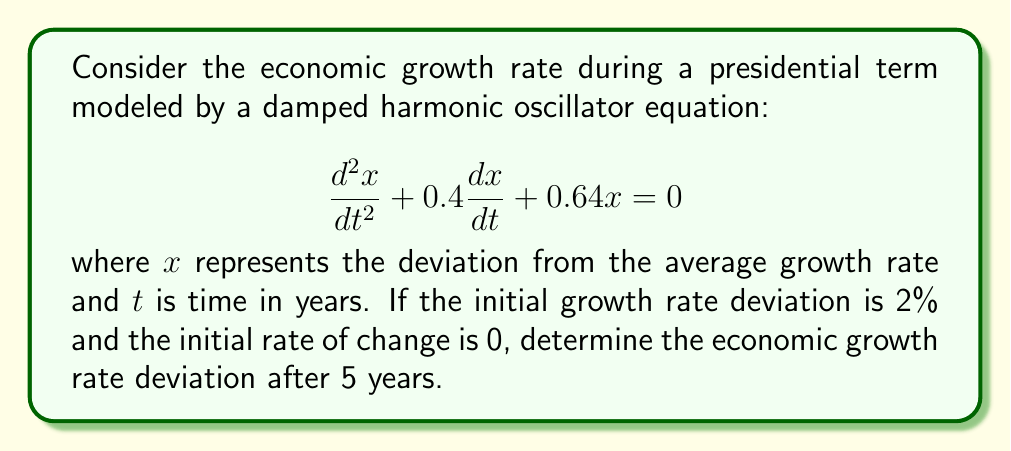Show me your answer to this math problem. To solve this problem, we'll follow these steps:

1) The general solution for a damped harmonic oscillator is:
   $$x(t) = e^{-\beta t}(A \cos(\omega t) + B \sin(\omega t))$$

   where $\beta$ is the damping factor and $\omega$ is the angular frequency.

2) From the given equation, we can identify:
   $$\beta = 0.2 \text{ and } \omega^2 = 0.64 - 0.2^2 = 0.60$$
   $$\omega = \sqrt{0.60} \approx 0.7746$$

3) Using the initial conditions:
   $x(0) = 2$ and $x'(0) = 0$

4) Applying these conditions to the general solution:
   $x(0) = A = 2$
   $x'(0) = -2\beta A + \omega B = 0$
   $B = \frac{2\beta A}{\omega} = \frac{2(0.2)(2)}{0.7746} \approx 1.0328$

5) Therefore, the solution is:
   $$x(t) = e^{-0.2t}(2 \cos(0.7746t) + 1.0328 \sin(0.7746t))$$

6) To find the deviation after 5 years, we evaluate $x(5)$:
   $$x(5) = e^{-0.2(5)}(2 \cos(0.7746(5)) + 1.0328 \sin(0.7746(5)))$$
   $$= e^{-1}(2 \cos(3.873) + 1.0328 \sin(3.873))$$
   $$\approx 0.3679(-1.5868 + 0.9972)$$
   $$\approx -0.2169$$
Answer: The economic growth rate deviation after 5 years is approximately -0.2169 or -21.69%. 